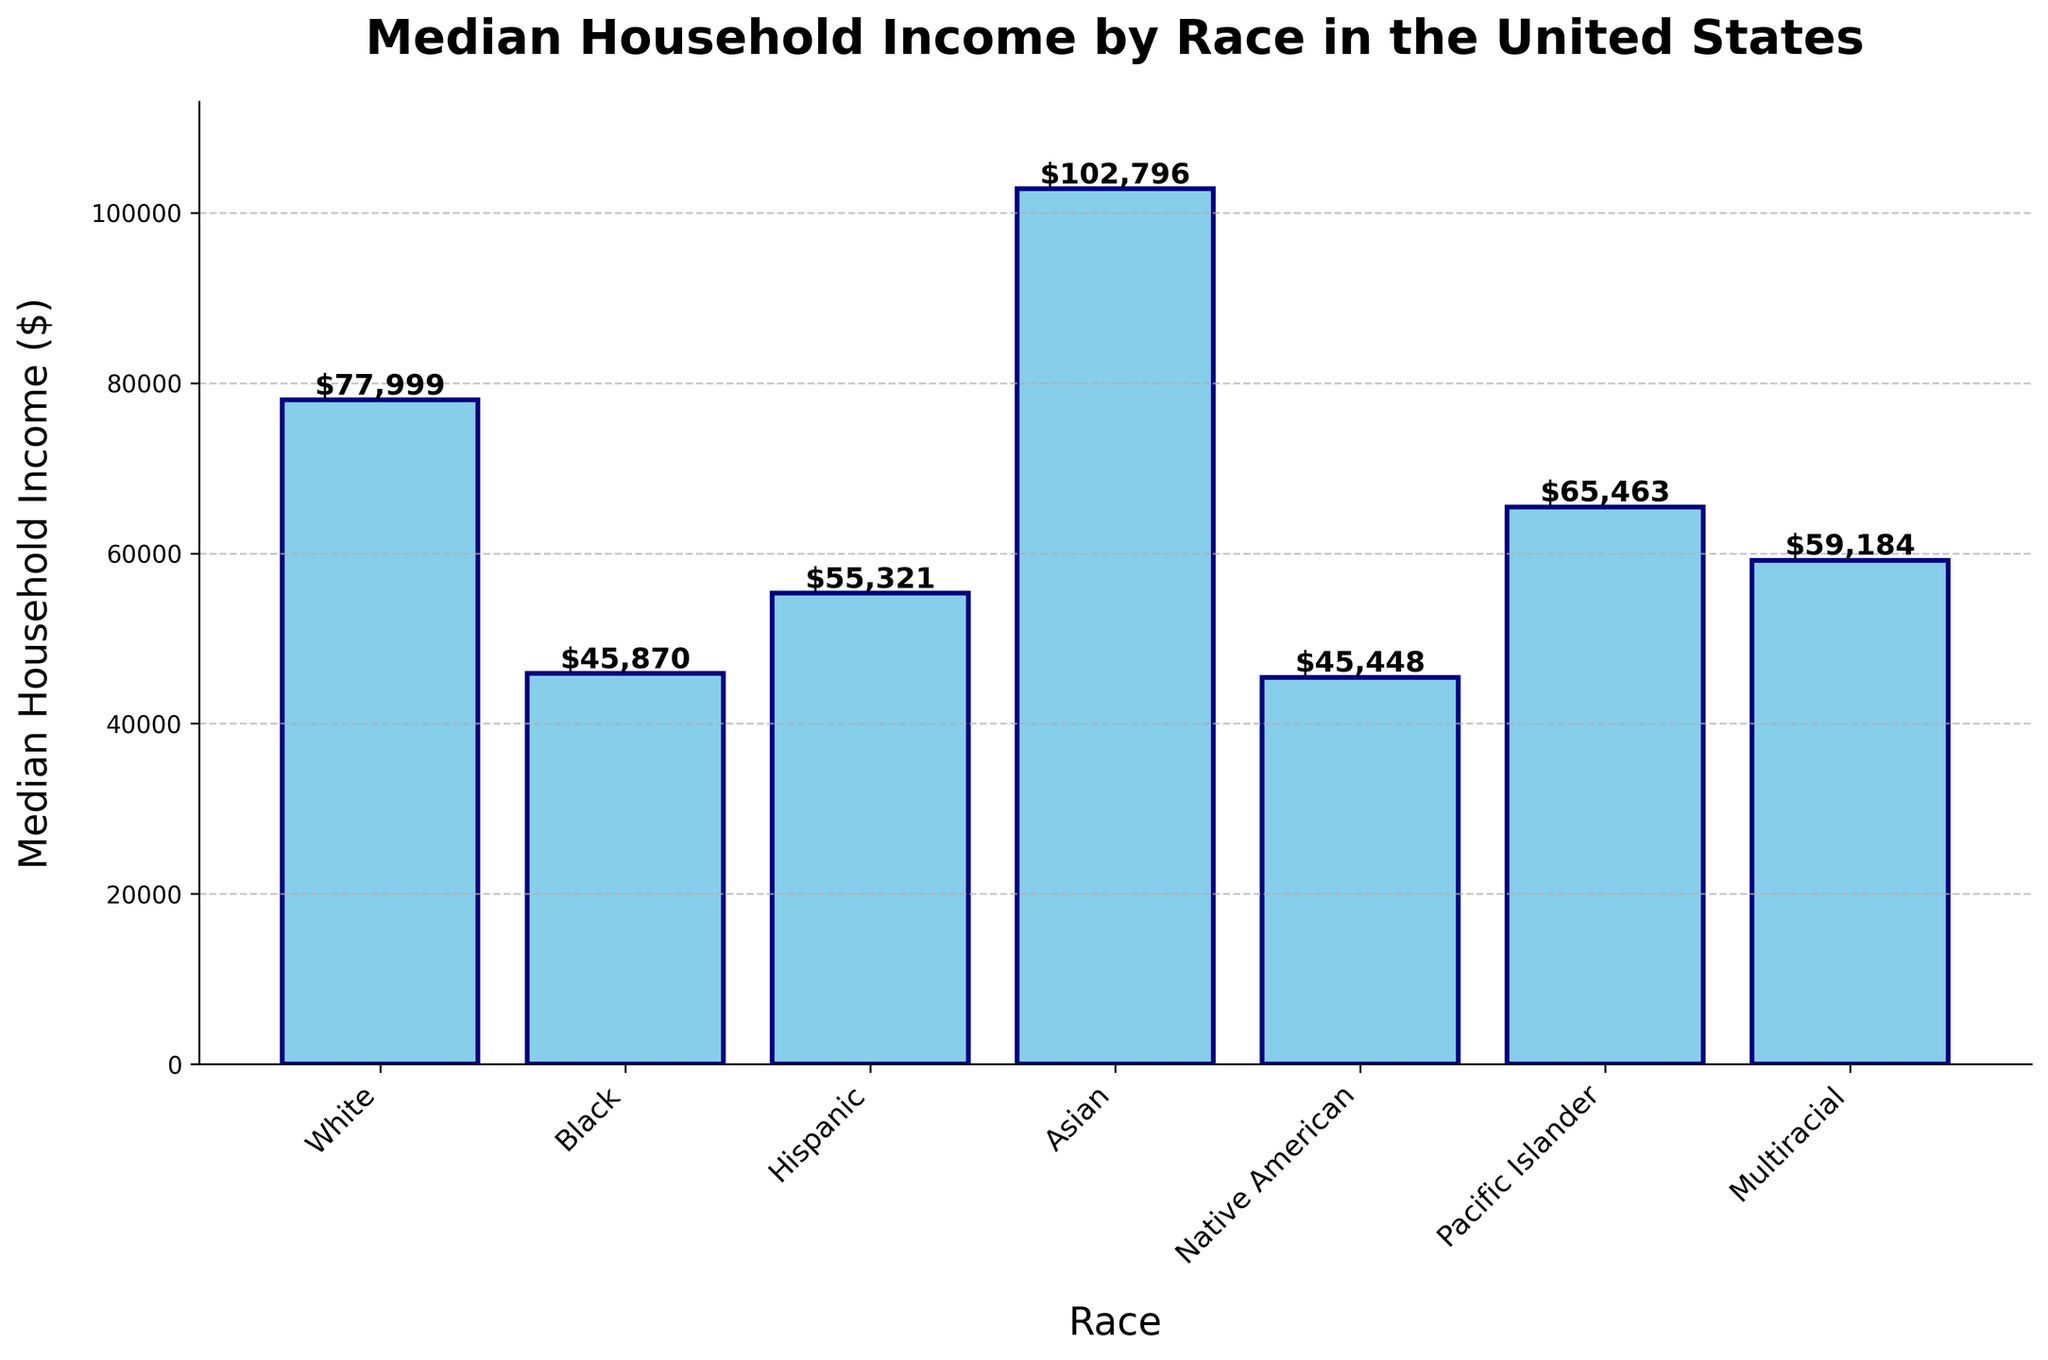Which racial group has the highest median household income? The figure shows the median household income for different racial groups. The bar corresponding to the Asian group is the tallest, indicating the highest income.
Answer: Asian Which racial group has the lowest median household income? The figure shows the median household income for different racial groups. The bar corresponding to Native American is the shortest, indicating the lowest income.
Answer: Native American How much higher is the median household income of Whites compared to Blacks? The median household income for Whites is $77,999 and for Blacks is $45,870. The difference between these two values is calculated by subtracting the income for Blacks from the income for Whites.
Answer: $32,129 What is the average median household income across all racial groups? Add all the median household incomes together and divide by the number of groups: (77999 + 45870 + 55321 + 102796 + 45448 + 65463 + 59184) / 7
Answer: $64,726 Which racial groups have a median household income greater than $60,000? The bars for White, Asian, Pacific Islander, and Multiracial extend above the $60,000 mark. These groups have a median household income greater than $60,000.
Answer: White, Asian, Pacific Islander, Multiracial What is the difference in median household income between the racial group with the highest income and the racial group with the lowest income? The highest median household income is for Asians at $102,796 and the lowest is for Native Americans at $45,448. The difference is calculated by subtracting the latter from the former.
Answer: $57,348 How does the median household income for Hispanics compare to that of Multiracials? The median household income for Hispanics is $55,321 and for Multiracials is $59,184. Since $59,184 is greater than $55,321, Multiracials have a higher median household income than Hispanics.
Answer: Multiracials have higher income Which racial group has a median household income closest to $50,000? The bars for Black and Native American groups are the closest to the $50,000 mark, with Black at $45,870 and Native American at $45,448. Native American is slightly closer.
Answer: Native American How much more income does the Asian group have compared to the Hispanic group? The median household income for Asians is $102,796 and for Hispanics is $55,321. The difference is calculated by subtracting the latter from the former.
Answer: $47,475 Which racial groups fall below the overall average median household income? Calculating the average median household income gives $64,726. The bars for Black, Hispanic, Native American, and Multiracial are below this value.
Answer: Black, Hispanic, Native American, Multiracial 